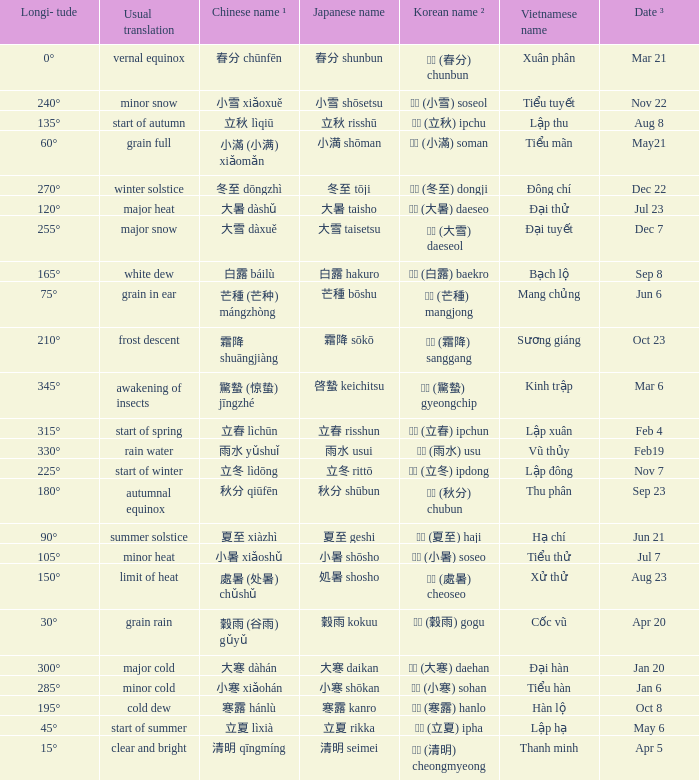Which Japanese name has a Korean name ² of 경칩 (驚蟄) gyeongchip? 啓蟄 keichitsu. 